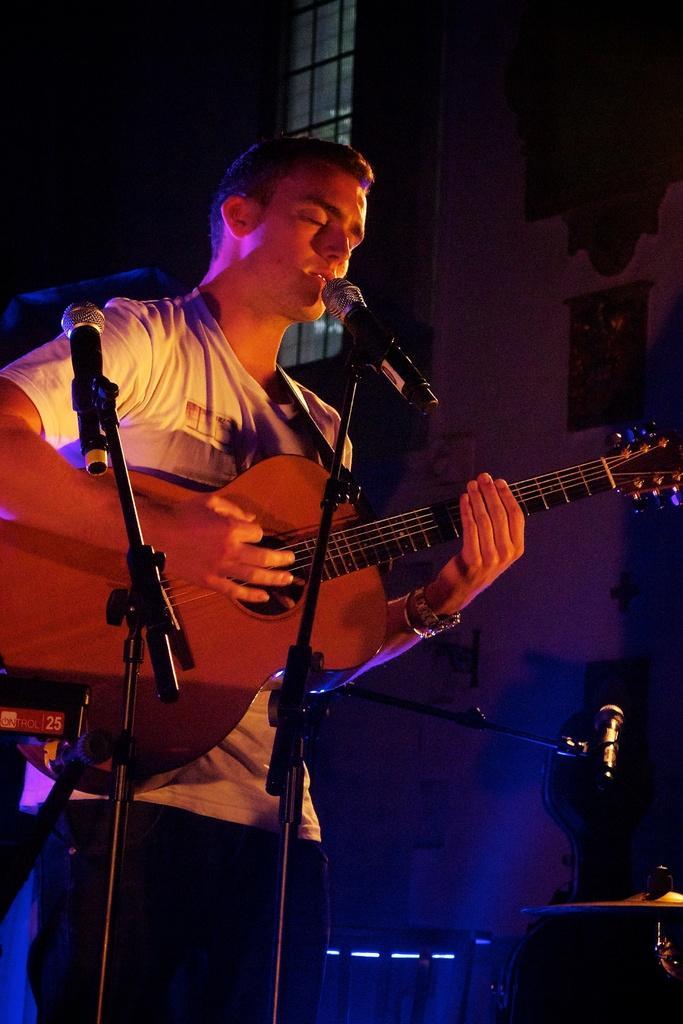Please provide a concise description of this image. In this picture we can see a man who is standing in front of mike and playing guitar. 